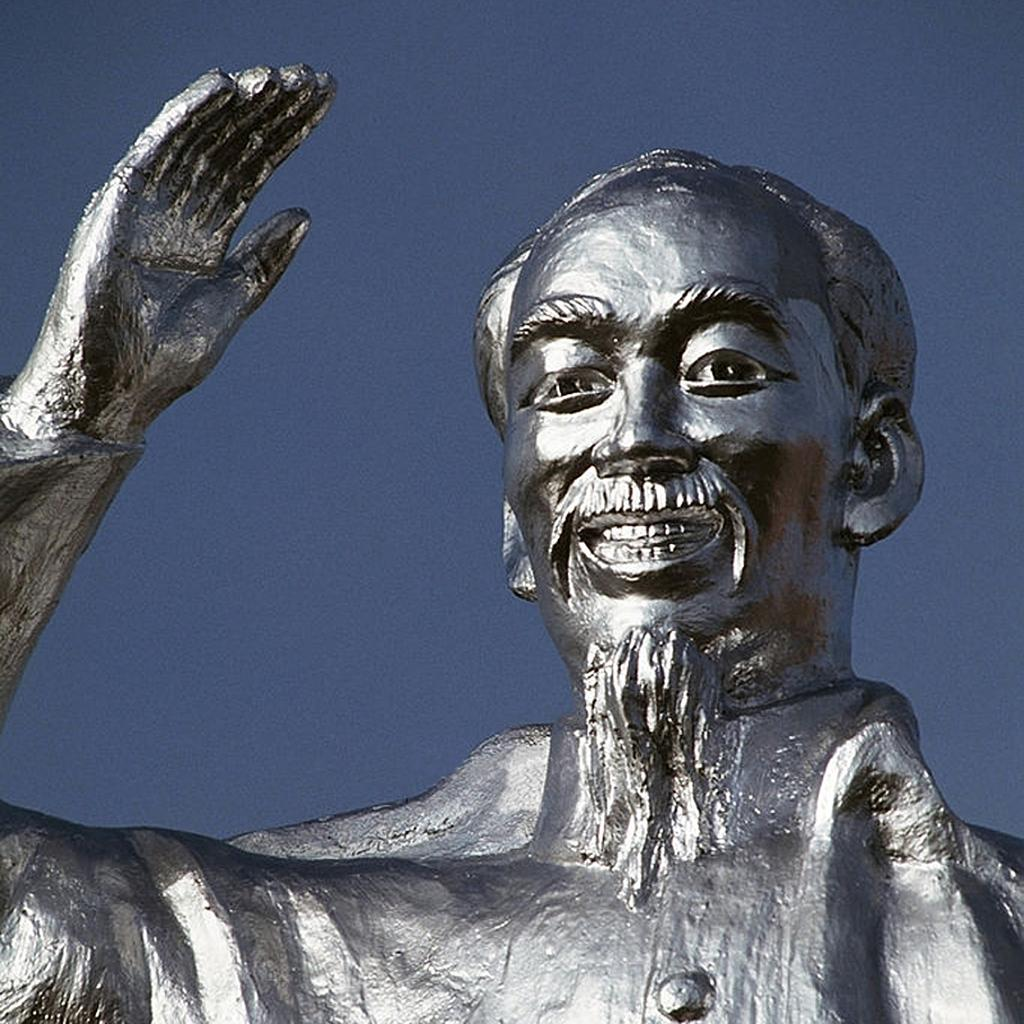What is the main subject of the image? There is a person statue in the image. What is the color of the statue? The statue is silver in color. What can be seen in the background of the image? The background of the image is blue. Are there any visible toes on the statue in the image? There is no indication of toes on the statue in the image, as it is a person statue made of silver. What type of grass can be seen growing around the statue in the image? There is no grass present in the image; it features a silver person statue against a blue background. 